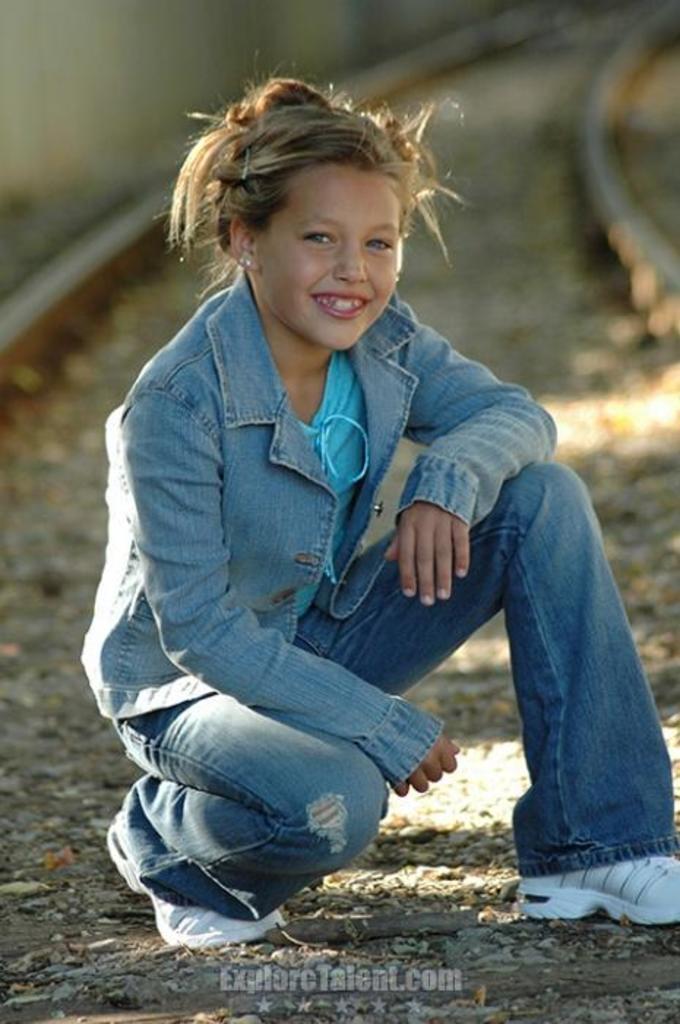Can you describe this image briefly? In the middle of the image we can see a girl and she is smiling, behind her we can see train track, at the bottom of the image we can find some text. 